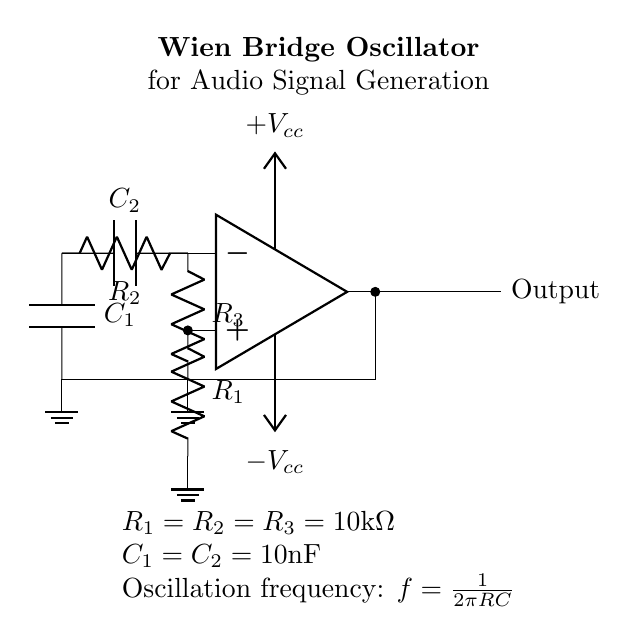What type of oscillator is represented in the circuit? The circuit is labeled as a Wien Bridge Oscillator, which is specifically designed for audio signal generation. This type of oscillator uses resistors and capacitors to create feedback necessary for oscillation.
Answer: Wien Bridge Oscillator What are the component values for the resistors in the circuit? The circuit indicates that the values for all resistors, labeled as R1, R2, and R3, are all 10 kilo-ohms. This is specified in the values section below the circuit.
Answer: 10 kilo-ohms What is the total capacitance in the circuit? The circuit contains two capacitors, C1 and C2, with each having a capacitance of 10 nanofarads. Since they are in parallel, the total capacitance is calculated as the sum of both values, which results in 20 nanofarads.
Answer: 20 nanofarads What is the oscillation frequency formula represented in the circuit? The circuit includes a notation that provides the oscillation frequency formula, which is f = 1 divided by 2πRC. This relationship expresses how frequency is determined by the product of resistance (R) and capacitance (C).
Answer: f = 1 / 2πRC Which components provide the necessary feedback for oscillation? In a Wien Bridge Oscillator, the feedback for oscillation is provided by the combination of resistors R1, R2, and the capacitors C1 and C2. The appropriate arrangement of these elements allows for controlled feedback and stable oscillation.
Answer: R1, R2, C1, C2 What happens to the amplified signal at the output? The output node of the op-amp delivers the amplified signal that is generated by the oscillation within the circuit. This output can then be used for audio applications as intended in the context of the Wien Bridge Oscillator design.
Answer: Amplified signal What is the significance of the power supply voltages in the circuit? The circuit indicates power supply voltages of +Vcc and -Vcc, which are essential for the op-amp to operate properly. This dual power supply enables the op-amp to output both positive and negative voltage levels, allowing for the oscillations required for audio generation.
Answer: +Vcc and -Vcc 